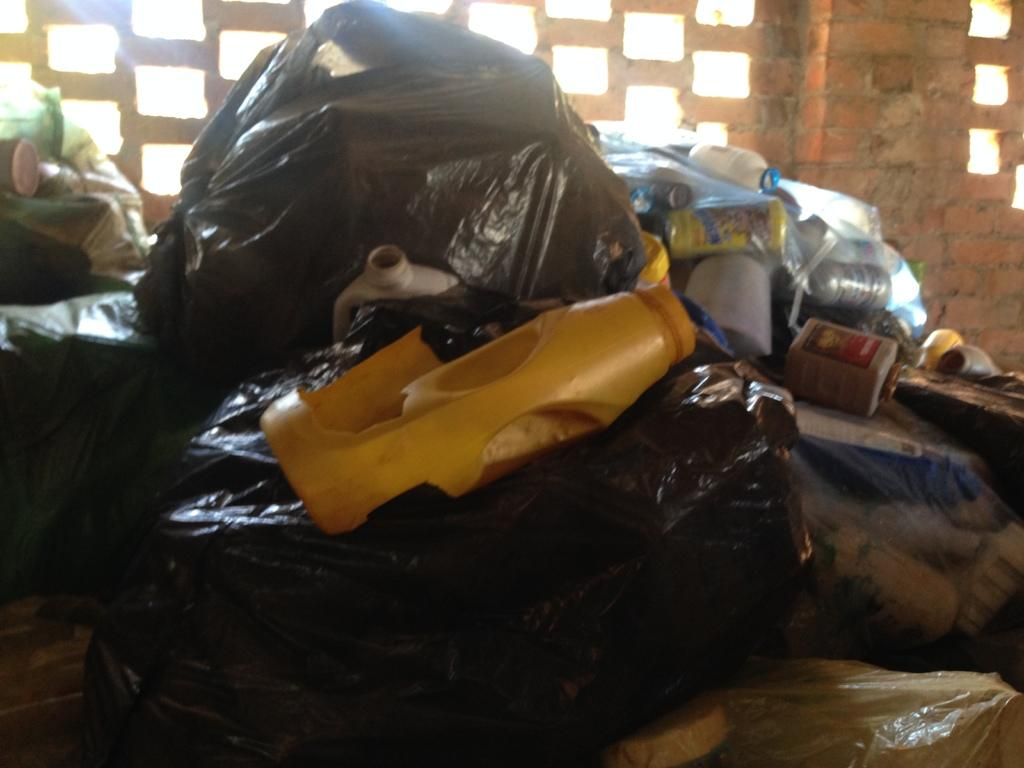What type of wall can be seen in the background of the image? There is a brick wall in the background of the image. Are there any specific features of the brick wall? Yes, the brick wall has gaps. What other items can be seen in the image besides the brick wall? There are black polythene covers, bottles, and other objects in the image. What invention is being exchanged between the people in the image? There are no people present in the image, and therefore no invention exchange can be observed. 